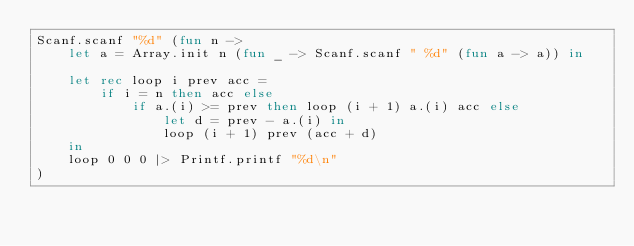Convert code to text. <code><loc_0><loc_0><loc_500><loc_500><_OCaml_>Scanf.scanf "%d" (fun n ->
    let a = Array.init n (fun _ -> Scanf.scanf " %d" (fun a -> a)) in

    let rec loop i prev acc =
        if i = n then acc else
            if a.(i) >= prev then loop (i + 1) a.(i) acc else
                let d = prev - a.(i) in
                loop (i + 1) prev (acc + d)
    in
    loop 0 0 0 |> Printf.printf "%d\n"
)</code> 